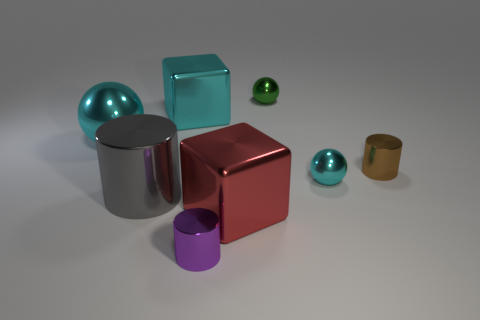Add 2 gray cylinders. How many objects exist? 10 Subtract all small cylinders. How many cylinders are left? 1 Subtract all red cubes. How many cyan balls are left? 2 Subtract all purple cylinders. How many cylinders are left? 2 Subtract all balls. How many objects are left? 5 Subtract 1 cubes. How many cubes are left? 1 Subtract all red cylinders. Subtract all spheres. How many objects are left? 5 Add 5 red things. How many red things are left? 6 Add 7 big cyan objects. How many big cyan objects exist? 9 Subtract 1 gray cylinders. How many objects are left? 7 